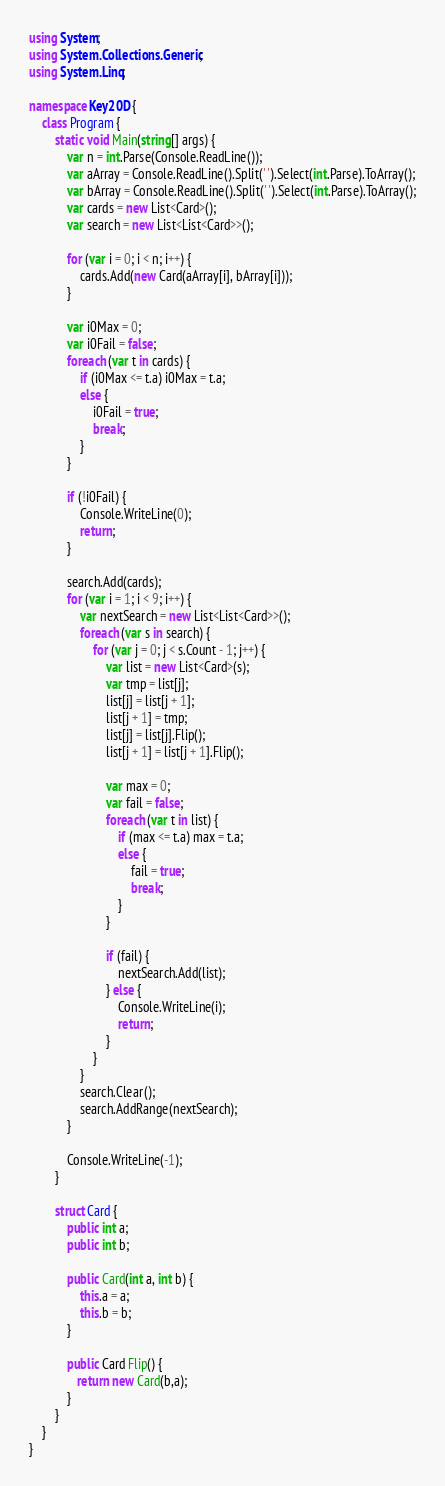<code> <loc_0><loc_0><loc_500><loc_500><_C#_>using System;
using System.Collections.Generic;
using System.Linq;

namespace Key20D {
    class Program {
        static void Main(string[] args) {
            var n = int.Parse(Console.ReadLine());
            var aArray = Console.ReadLine().Split(' ').Select(int.Parse).ToArray();
            var bArray = Console.ReadLine().Split(' ').Select(int.Parse).ToArray();
            var cards = new List<Card>();
            var search = new List<List<Card>>();
            
            for (var i = 0; i < n; i++) {
                cards.Add(new Card(aArray[i], bArray[i]));
            }

            var i0Max = 0;
            var i0Fail = false;
            foreach (var t in cards) {
                if (i0Max <= t.a) i0Max = t.a;
                else {
                    i0Fail = true;
                    break;
                }
            }

            if (!i0Fail) {
                Console.WriteLine(0);
                return;
            }
            
            search.Add(cards);
            for (var i = 1; i < 9; i++) {
                var nextSearch = new List<List<Card>>();
                foreach (var s in search) {
                    for (var j = 0; j < s.Count - 1; j++) {
                        var list = new List<Card>(s);
                        var tmp = list[j];
                        list[j] = list[j + 1];
                        list[j + 1] = tmp;
                        list[j] = list[j].Flip();
                        list[j + 1] = list[j + 1].Flip();

                        var max = 0;
                        var fail = false;
                        foreach (var t in list) {
                            if (max <= t.a) max = t.a;
                            else {
                                fail = true;
                                break;
                            }
                        }

                        if (fail) {
                            nextSearch.Add(list);
                        } else {
                            Console.WriteLine(i);
                            return;
                        }
                    }
                }
                search.Clear();
                search.AddRange(nextSearch);
            }

            Console.WriteLine(-1);
        }

        struct Card {
            public int a;
            public int b;

            public Card(int a, int b) {
                this.a = a;
                this.b = b;
            }

            public Card Flip() {
               return new Card(b,a);
            }
        }
    }
}</code> 